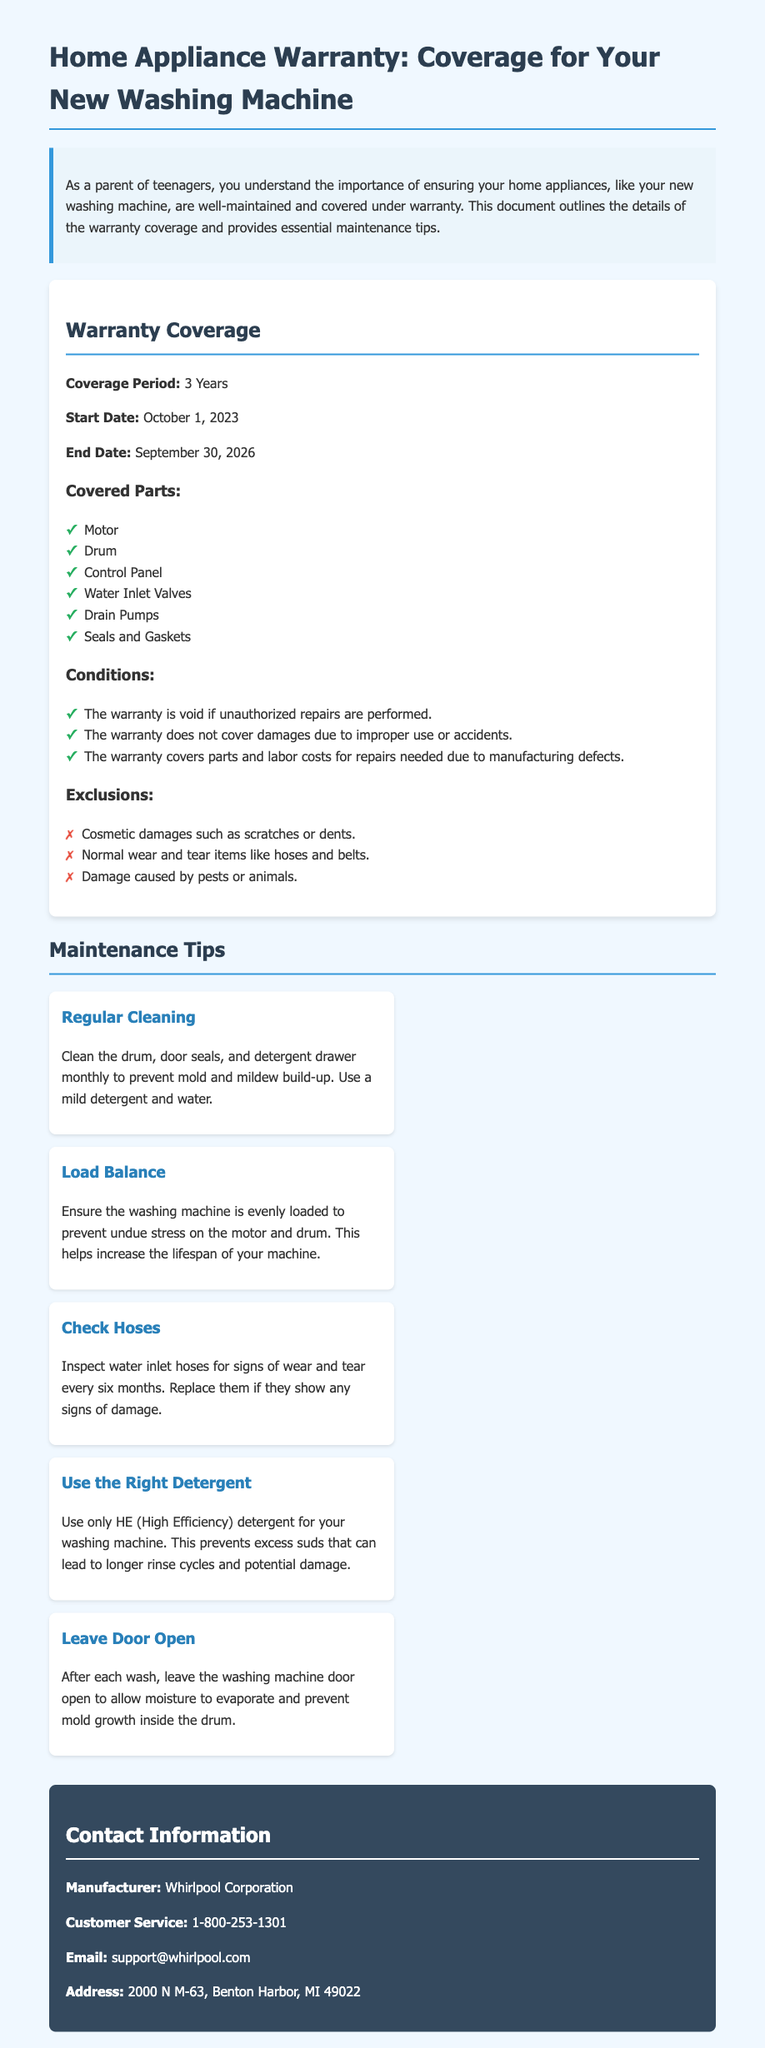What is the coverage period of the warranty? The coverage period is stated in the warranty document, indicating the duration that the warranty is active, which is 3 years.
Answer: 3 Years When does the warranty start? The start date of the warranty is provided in the document, which specifies when the warranty coverage begins, on October 1, 2023.
Answer: October 1, 2023 What part is covered related to water management? The document lists covered parts, and water management corresponds to one of those parts, which is water inlet valves.
Answer: Water Inlet Valves What should you do to prevent mold growth? The maintenance tips suggest an action to take after each wash to prevent mold growth in the washing machine, which is leaving the door open.
Answer: Leave Door Open Is cosmetic damage covered? The warranty document outlines exclusions, and it specifies that cosmetic damages are not covered under the warranty.
Answer: No How often should you check the hoses? The maintenance tips indicate a specific frequency for checking the water inlet hoses for wear and tear, which is every six months.
Answer: Every six months What should you use to clean the washing machine? The document discusses cleaning recommendations, particularly mentioning the type of product recommended for use, which is mild detergent and water.
Answer: Mild detergent and water What is the customer service phone number? The contact information section provides a specific detail for reaching customer service, which is important for warranty inquiries, listed as 1-800-253-1301.
Answer: 1-800-253-1301 